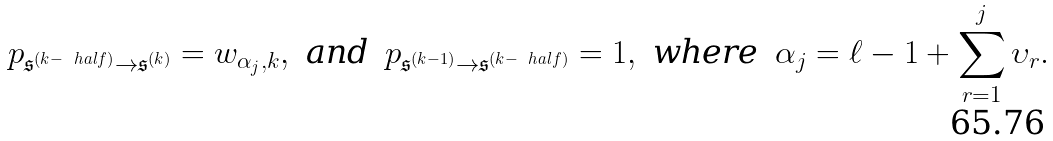<formula> <loc_0><loc_0><loc_500><loc_500>p _ { \mathfrak { s } ^ { ( k - \ h a l f ) } \to \mathfrak { s } ^ { ( k ) } } = w _ { \alpha _ { j } , k } , & & \text {and} & & p _ { \mathfrak { s } ^ { ( k - 1 ) } \to \mathfrak { s } ^ { ( k - \ h a l f ) } } = 1 , & & \text {where} & & \alpha _ { j } = \ell - 1 + \sum _ { r = 1 } ^ { j } \upsilon _ { r } .</formula> 